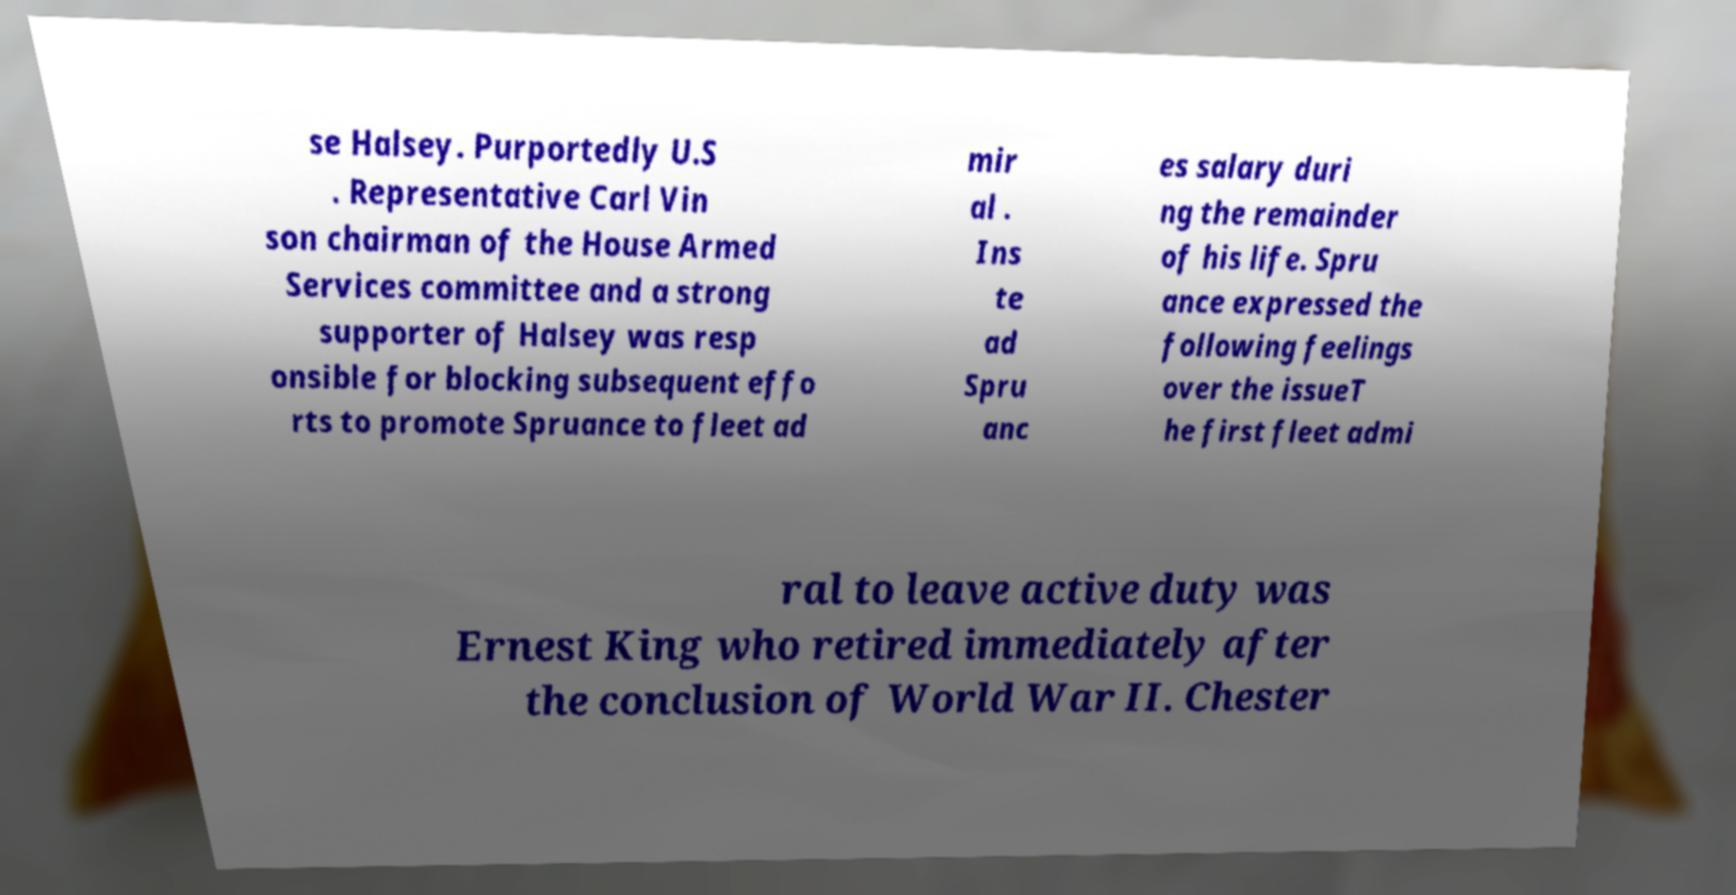Could you assist in decoding the text presented in this image and type it out clearly? se Halsey. Purportedly U.S . Representative Carl Vin son chairman of the House Armed Services committee and a strong supporter of Halsey was resp onsible for blocking subsequent effo rts to promote Spruance to fleet ad mir al . Ins te ad Spru anc es salary duri ng the remainder of his life. Spru ance expressed the following feelings over the issueT he first fleet admi ral to leave active duty was Ernest King who retired immediately after the conclusion of World War II. Chester 